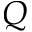<formula> <loc_0><loc_0><loc_500><loc_500>Q</formula> 